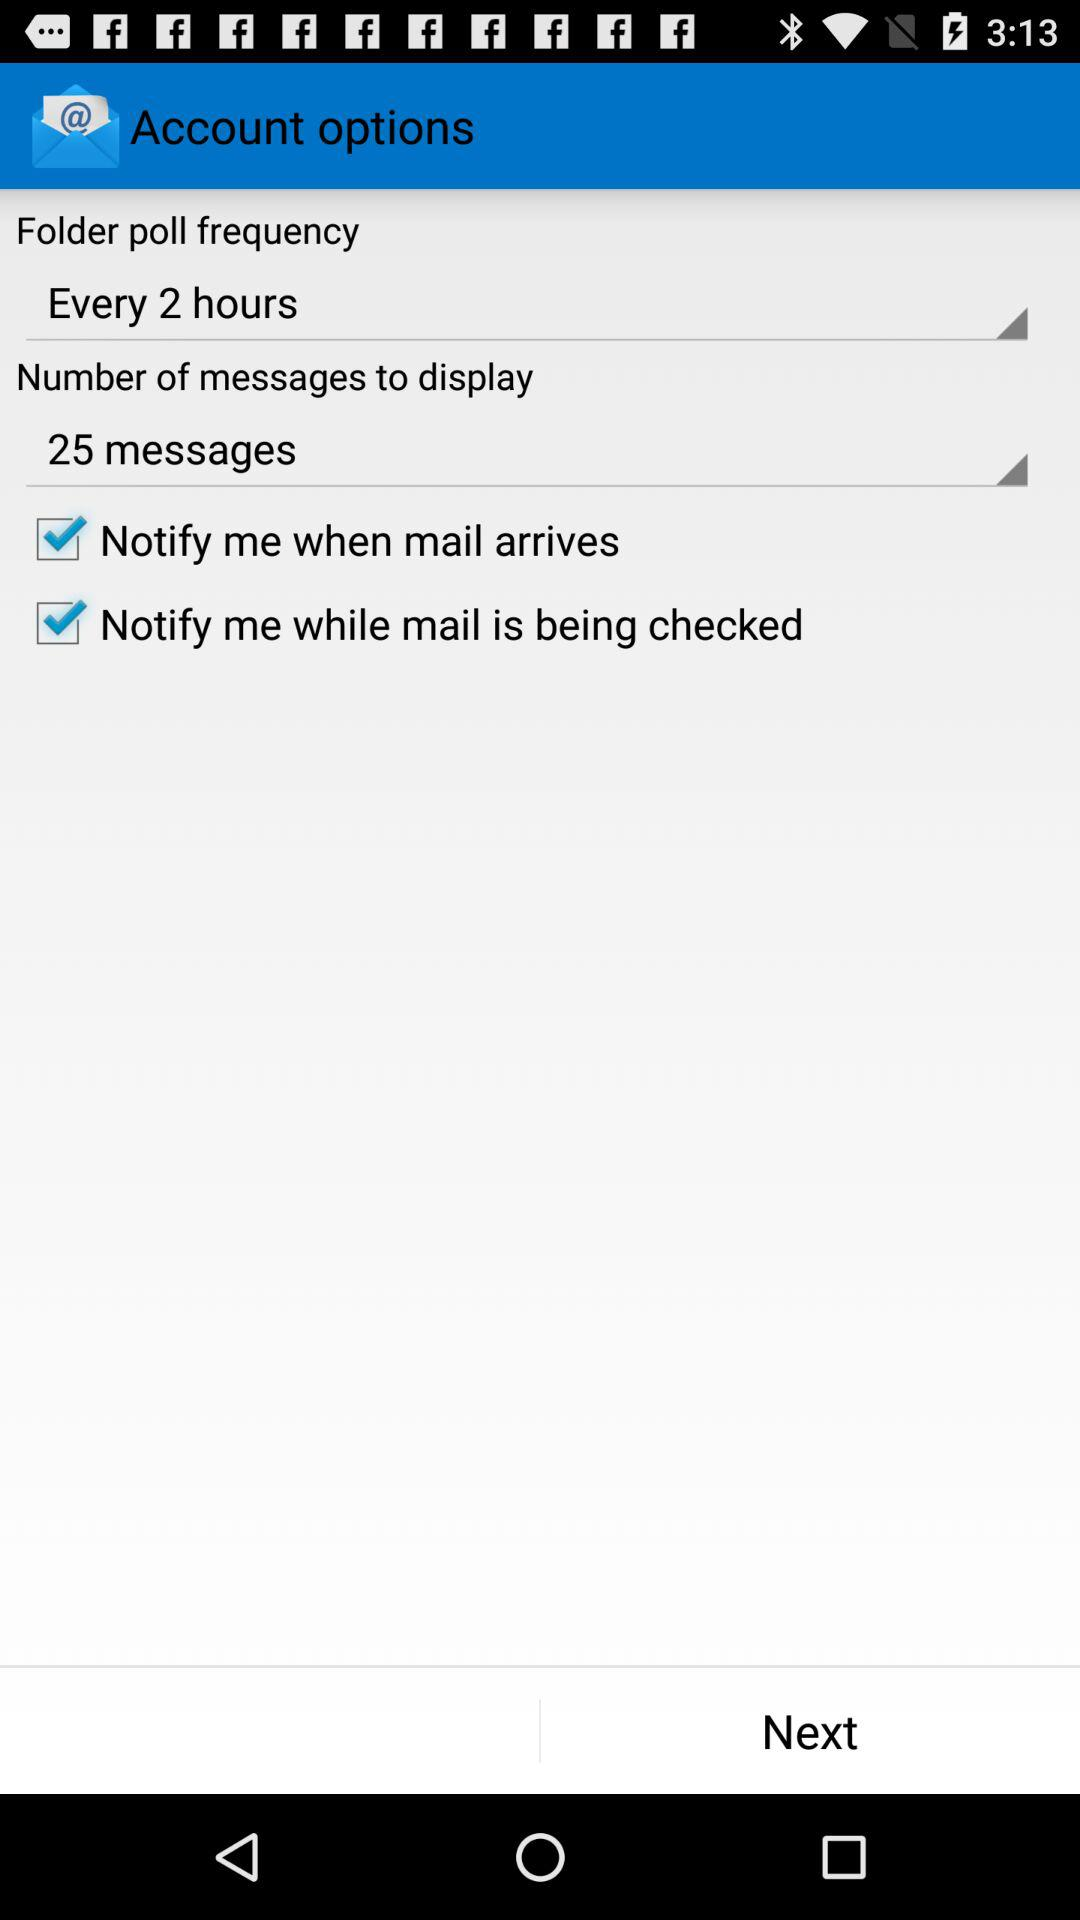Which email address is used for the account?
When the provided information is insufficient, respond with <no answer>. <no answer> 